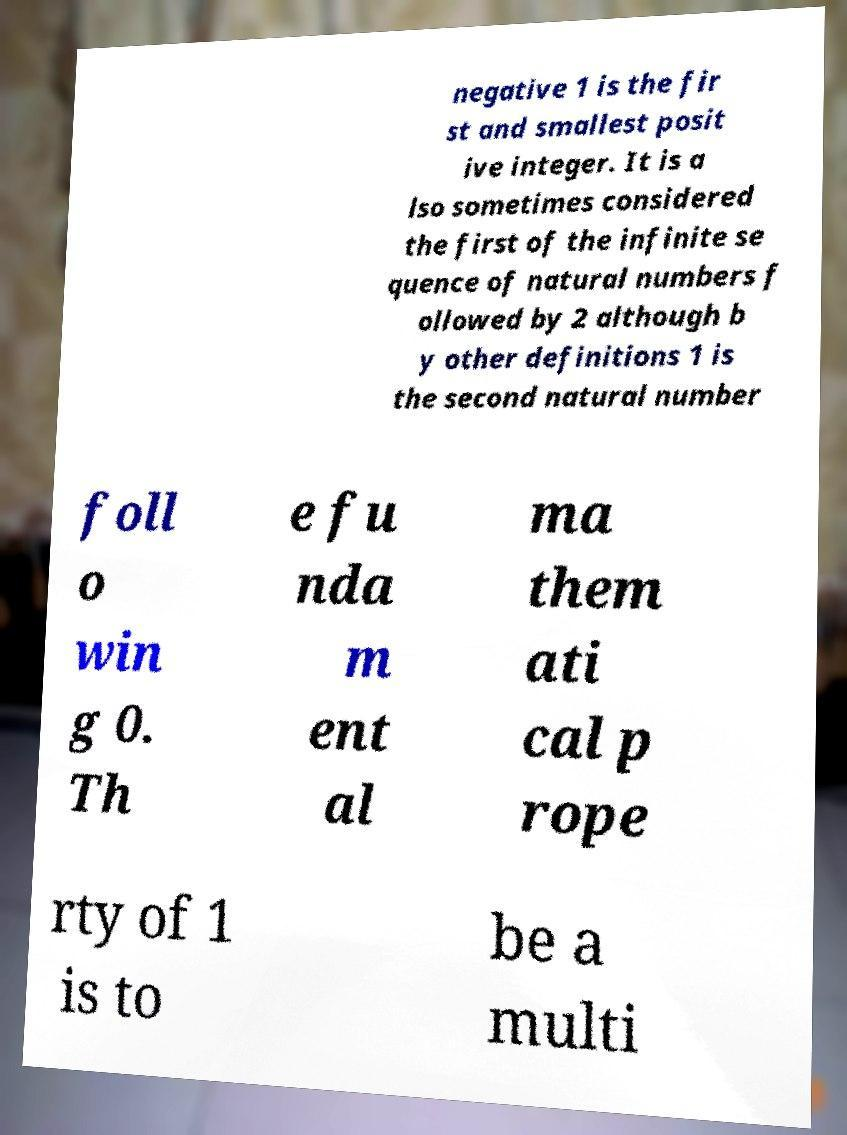Could you extract and type out the text from this image? negative 1 is the fir st and smallest posit ive integer. It is a lso sometimes considered the first of the infinite se quence of natural numbers f ollowed by 2 although b y other definitions 1 is the second natural number foll o win g 0. Th e fu nda m ent al ma them ati cal p rope rty of 1 is to be a multi 